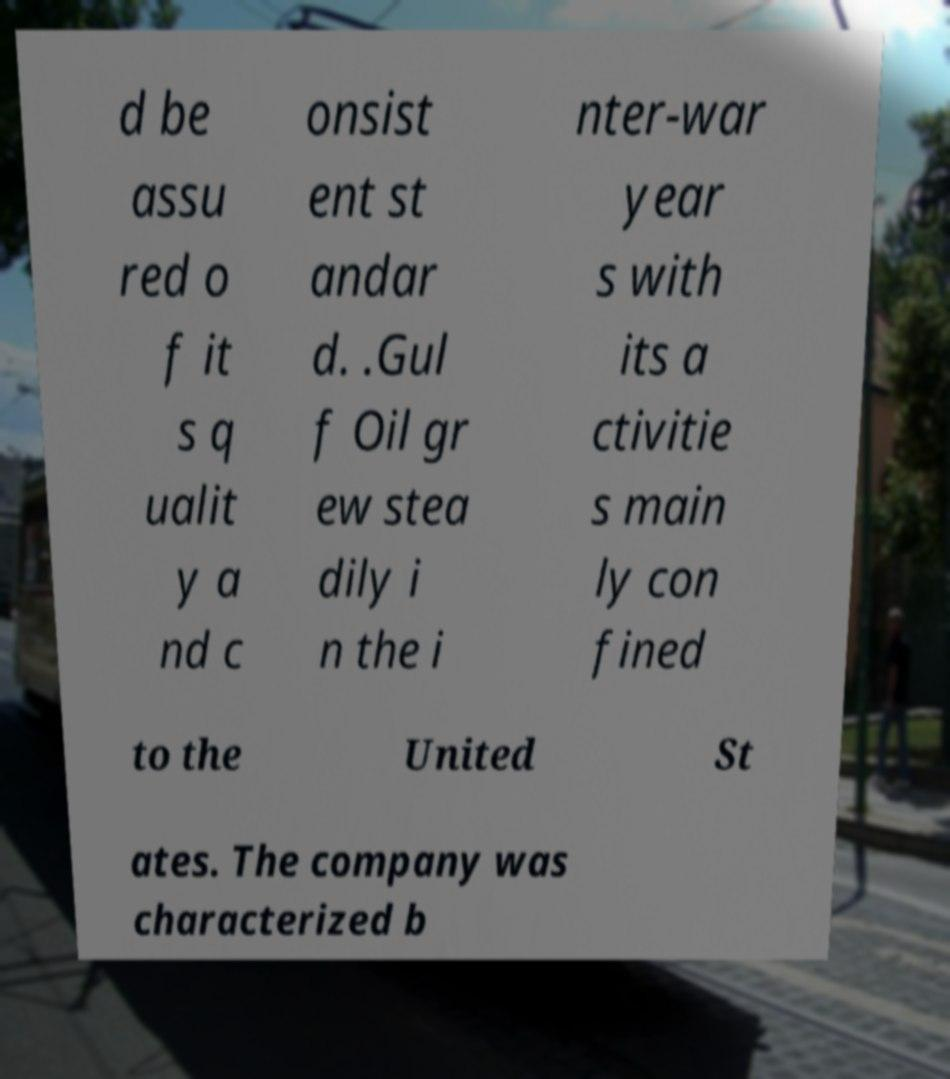Could you assist in decoding the text presented in this image and type it out clearly? d be assu red o f it s q ualit y a nd c onsist ent st andar d. .Gul f Oil gr ew stea dily i n the i nter-war year s with its a ctivitie s main ly con fined to the United St ates. The company was characterized b 